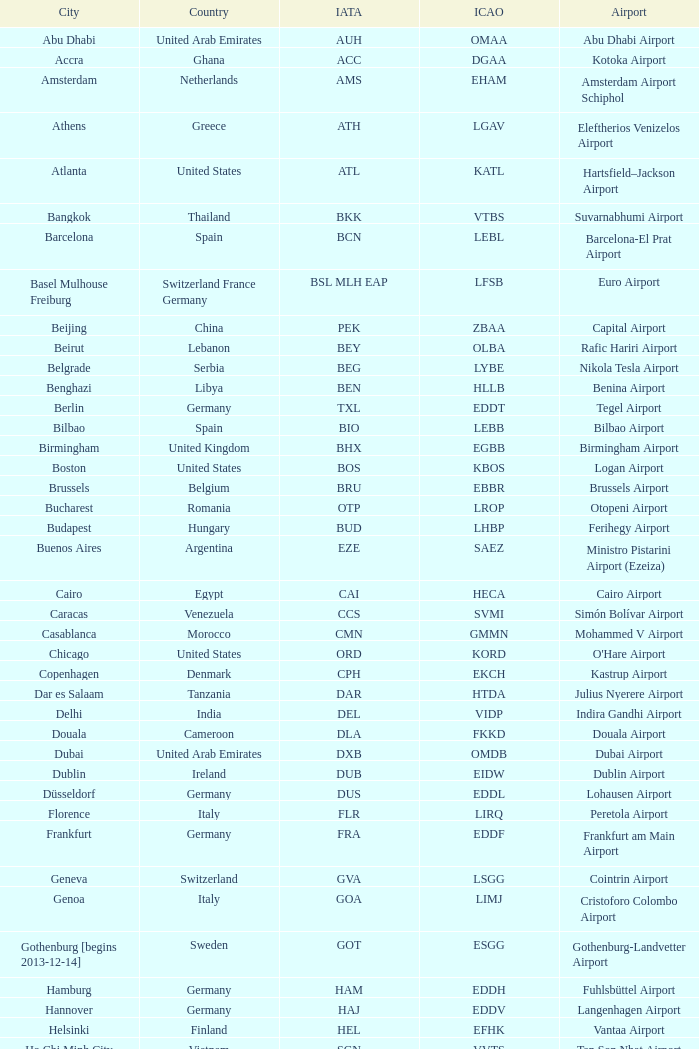Parse the full table. {'header': ['City', 'Country', 'IATA', 'ICAO', 'Airport'], 'rows': [['Abu Dhabi', 'United Arab Emirates', 'AUH', 'OMAA', 'Abu Dhabi Airport'], ['Accra', 'Ghana', 'ACC', 'DGAA', 'Kotoka Airport'], ['Amsterdam', 'Netherlands', 'AMS', 'EHAM', 'Amsterdam Airport Schiphol'], ['Athens', 'Greece', 'ATH', 'LGAV', 'Eleftherios Venizelos Airport'], ['Atlanta', 'United States', 'ATL', 'KATL', 'Hartsfield–Jackson Airport'], ['Bangkok', 'Thailand', 'BKK', 'VTBS', 'Suvarnabhumi Airport'], ['Barcelona', 'Spain', 'BCN', 'LEBL', 'Barcelona-El Prat Airport'], ['Basel Mulhouse Freiburg', 'Switzerland France Germany', 'BSL MLH EAP', 'LFSB', 'Euro Airport'], ['Beijing', 'China', 'PEK', 'ZBAA', 'Capital Airport'], ['Beirut', 'Lebanon', 'BEY', 'OLBA', 'Rafic Hariri Airport'], ['Belgrade', 'Serbia', 'BEG', 'LYBE', 'Nikola Tesla Airport'], ['Benghazi', 'Libya', 'BEN', 'HLLB', 'Benina Airport'], ['Berlin', 'Germany', 'TXL', 'EDDT', 'Tegel Airport'], ['Bilbao', 'Spain', 'BIO', 'LEBB', 'Bilbao Airport'], ['Birmingham', 'United Kingdom', 'BHX', 'EGBB', 'Birmingham Airport'], ['Boston', 'United States', 'BOS', 'KBOS', 'Logan Airport'], ['Brussels', 'Belgium', 'BRU', 'EBBR', 'Brussels Airport'], ['Bucharest', 'Romania', 'OTP', 'LROP', 'Otopeni Airport'], ['Budapest', 'Hungary', 'BUD', 'LHBP', 'Ferihegy Airport'], ['Buenos Aires', 'Argentina', 'EZE', 'SAEZ', 'Ministro Pistarini Airport (Ezeiza)'], ['Cairo', 'Egypt', 'CAI', 'HECA', 'Cairo Airport'], ['Caracas', 'Venezuela', 'CCS', 'SVMI', 'Simón Bolívar Airport'], ['Casablanca', 'Morocco', 'CMN', 'GMMN', 'Mohammed V Airport'], ['Chicago', 'United States', 'ORD', 'KORD', "O'Hare Airport"], ['Copenhagen', 'Denmark', 'CPH', 'EKCH', 'Kastrup Airport'], ['Dar es Salaam', 'Tanzania', 'DAR', 'HTDA', 'Julius Nyerere Airport'], ['Delhi', 'India', 'DEL', 'VIDP', 'Indira Gandhi Airport'], ['Douala', 'Cameroon', 'DLA', 'FKKD', 'Douala Airport'], ['Dubai', 'United Arab Emirates', 'DXB', 'OMDB', 'Dubai Airport'], ['Dublin', 'Ireland', 'DUB', 'EIDW', 'Dublin Airport'], ['Düsseldorf', 'Germany', 'DUS', 'EDDL', 'Lohausen Airport'], ['Florence', 'Italy', 'FLR', 'LIRQ', 'Peretola Airport'], ['Frankfurt', 'Germany', 'FRA', 'EDDF', 'Frankfurt am Main Airport'], ['Geneva', 'Switzerland', 'GVA', 'LSGG', 'Cointrin Airport'], ['Genoa', 'Italy', 'GOA', 'LIMJ', 'Cristoforo Colombo Airport'], ['Gothenburg [begins 2013-12-14]', 'Sweden', 'GOT', 'ESGG', 'Gothenburg-Landvetter Airport'], ['Hamburg', 'Germany', 'HAM', 'EDDH', 'Fuhlsbüttel Airport'], ['Hannover', 'Germany', 'HAJ', 'EDDV', 'Langenhagen Airport'], ['Helsinki', 'Finland', 'HEL', 'EFHK', 'Vantaa Airport'], ['Ho Chi Minh City', 'Vietnam', 'SGN', 'VVTS', 'Tan Son Nhat Airport'], ['Hong Kong', 'Hong Kong', 'HKG', 'VHHH', 'Chek Lap Kok Airport'], ['Istanbul', 'Turkey', 'IST', 'LTBA', 'Atatürk Airport'], ['Jakarta', 'Indonesia', 'CGK', 'WIII', 'Soekarno–Hatta Airport'], ['Jeddah', 'Saudi Arabia', 'JED', 'OEJN', 'King Abdulaziz Airport'], ['Johannesburg', 'South Africa', 'JNB', 'FAJS', 'OR Tambo Airport'], ['Karachi', 'Pakistan', 'KHI', 'OPKC', 'Jinnah Airport'], ['Kiev', 'Ukraine', 'KBP', 'UKBB', 'Boryspil International Airport'], ['Lagos', 'Nigeria', 'LOS', 'DNMM', 'Murtala Muhammed Airport'], ['Libreville', 'Gabon', 'LBV', 'FOOL', "Leon M'ba Airport"], ['Lisbon', 'Portugal', 'LIS', 'LPPT', 'Portela Airport'], ['London', 'United Kingdom', 'LCY', 'EGLC', 'City Airport'], ['London [begins 2013-12-14]', 'United Kingdom', 'LGW', 'EGKK', 'Gatwick Airport'], ['London', 'United Kingdom', 'LHR', 'EGLL', 'Heathrow Airport'], ['Los Angeles', 'United States', 'LAX', 'KLAX', 'Los Angeles International Airport'], ['Lugano', 'Switzerland', 'LUG', 'LSZA', 'Agno Airport'], ['Luxembourg City', 'Luxembourg', 'LUX', 'ELLX', 'Findel Airport'], ['Lyon', 'France', 'LYS', 'LFLL', 'Saint-Exupéry Airport'], ['Madrid', 'Spain', 'MAD', 'LEMD', 'Madrid-Barajas Airport'], ['Malabo', 'Equatorial Guinea', 'SSG', 'FGSL', 'Saint Isabel Airport'], ['Malaga', 'Spain', 'AGP', 'LEMG', 'Málaga-Costa del Sol Airport'], ['Manchester', 'United Kingdom', 'MAN', 'EGCC', 'Ringway Airport'], ['Manila', 'Philippines', 'MNL', 'RPLL', 'Ninoy Aquino Airport'], ['Marrakech [begins 2013-11-01]', 'Morocco', 'RAK', 'GMMX', 'Menara Airport'], ['Miami', 'United States', 'MIA', 'KMIA', 'Miami Airport'], ['Milan', 'Italy', 'MXP', 'LIMC', 'Malpensa Airport'], ['Minneapolis', 'United States', 'MSP', 'KMSP', 'Minneapolis Airport'], ['Montreal', 'Canada', 'YUL', 'CYUL', 'Pierre Elliott Trudeau Airport'], ['Moscow', 'Russia', 'DME', 'UUDD', 'Domodedovo Airport'], ['Mumbai', 'India', 'BOM', 'VABB', 'Chhatrapati Shivaji Airport'], ['Munich', 'Germany', 'MUC', 'EDDM', 'Franz Josef Strauss Airport'], ['Muscat', 'Oman', 'MCT', 'OOMS', 'Seeb Airport'], ['Nairobi', 'Kenya', 'NBO', 'HKJK', 'Jomo Kenyatta Airport'], ['Newark', 'United States', 'EWR', 'KEWR', 'Liberty Airport'], ['New York City', 'United States', 'JFK', 'KJFK', 'John F Kennedy Airport'], ['Nice', 'France', 'NCE', 'LFMN', "Côte d'Azur Airport"], ['Nuremberg', 'Germany', 'NUE', 'EDDN', 'Nuremberg Airport'], ['Oslo', 'Norway', 'OSL', 'ENGM', 'Gardermoen Airport'], ['Palma de Mallorca', 'Spain', 'PMI', 'LFPA', 'Palma de Mallorca Airport'], ['Paris', 'France', 'CDG', 'LFPG', 'Charles de Gaulle Airport'], ['Porto', 'Portugal', 'OPO', 'LPPR', 'Francisco de Sa Carneiro Airport'], ['Prague', 'Czech Republic', 'PRG', 'LKPR', 'Ruzyně Airport'], ['Riga', 'Latvia', 'RIX', 'EVRA', 'Riga Airport'], ['Rio de Janeiro [resumes 2014-7-14]', 'Brazil', 'GIG', 'SBGL', 'Galeão Airport'], ['Riyadh', 'Saudi Arabia', 'RUH', 'OERK', 'King Khalid Airport'], ['Rome', 'Italy', 'FCO', 'LIRF', 'Leonardo da Vinci Airport'], ['Saint Petersburg', 'Russia', 'LED', 'ULLI', 'Pulkovo Airport'], ['San Francisco', 'United States', 'SFO', 'KSFO', 'San Francisco Airport'], ['Santiago', 'Chile', 'SCL', 'SCEL', 'Comodoro Arturo Benitez Airport'], ['São Paulo', 'Brazil', 'GRU', 'SBGR', 'Guarulhos Airport'], ['Sarajevo', 'Bosnia and Herzegovina', 'SJJ', 'LQSA', 'Butmir Airport'], ['Seattle', 'United States', 'SEA', 'KSEA', 'Sea-Tac Airport'], ['Shanghai', 'China', 'PVG', 'ZSPD', 'Pudong Airport'], ['Singapore', 'Singapore', 'SIN', 'WSSS', 'Changi Airport'], ['Skopje', 'Republic of Macedonia', 'SKP', 'LWSK', 'Alexander the Great Airport'], ['Sofia', 'Bulgaria', 'SOF', 'LBSF', 'Vrazhdebna Airport'], ['Stockholm', 'Sweden', 'ARN', 'ESSA', 'Arlanda Airport'], ['Stuttgart', 'Germany', 'STR', 'EDDS', 'Echterdingen Airport'], ['Taipei', 'Taiwan', 'TPE', 'RCTP', 'Taoyuan Airport'], ['Tehran', 'Iran', 'IKA', 'OIIE', 'Imam Khomeini Airport'], ['Tel Aviv', 'Israel', 'TLV', 'LLBG', 'Ben Gurion Airport'], ['Thessaloniki', 'Greece', 'SKG', 'LGTS', 'Macedonia Airport'], ['Tirana', 'Albania', 'TIA', 'LATI', 'Nënë Tereza Airport'], ['Tokyo', 'Japan', 'NRT', 'RJAA', 'Narita Airport'], ['Toronto', 'Canada', 'YYZ', 'CYYZ', 'Pearson Airport'], ['Tripoli', 'Libya', 'TIP', 'HLLT', 'Tripoli Airport'], ['Tunis', 'Tunisia', 'TUN', 'DTTA', 'Carthage Airport'], ['Turin', 'Italy', 'TRN', 'LIMF', 'Sandro Pertini Airport'], ['Valencia', 'Spain', 'VLC', 'LEVC', 'Valencia Airport'], ['Venice', 'Italy', 'VCE', 'LIPZ', 'Marco Polo Airport'], ['Vienna', 'Austria', 'VIE', 'LOWW', 'Schwechat Airport'], ['Warsaw', 'Poland', 'WAW', 'EPWA', 'Frederic Chopin Airport'], ['Washington DC', 'United States', 'IAD', 'KIAD', 'Dulles Airport'], ['Yaounde', 'Cameroon', 'NSI', 'FKYS', 'Yaounde Nsimalen Airport'], ['Yerevan', 'Armenia', 'EVN', 'UDYZ', 'Zvartnots Airport'], ['Zurich', 'Switzerland', 'ZRH', 'LSZH', 'Zurich Airport']]} What is the iata code for galeão airport? GIG. 